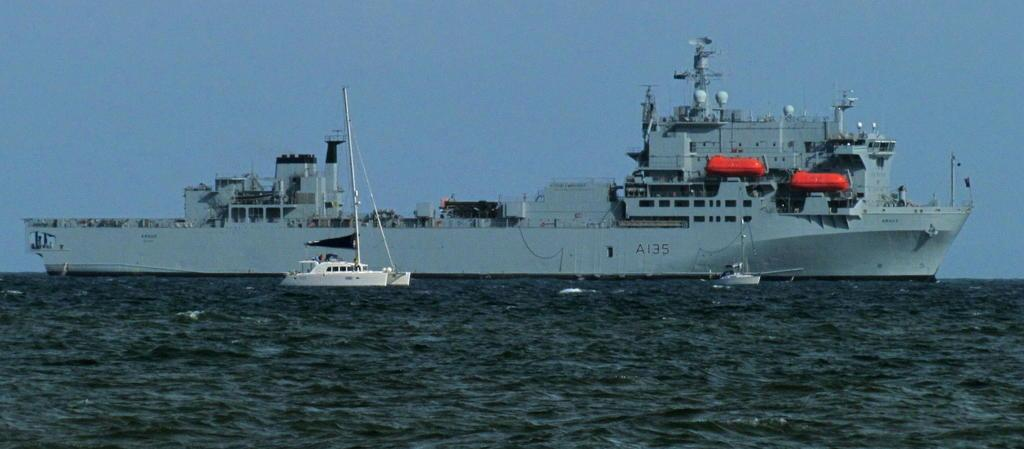<image>
Share a concise interpretation of the image provided. A large ship has an identification of A135 on the side. 